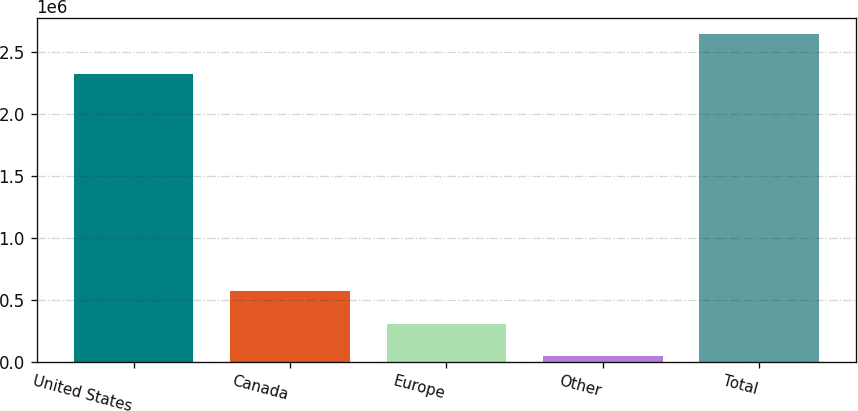<chart> <loc_0><loc_0><loc_500><loc_500><bar_chart><fcel>United States<fcel>Canada<fcel>Europe<fcel>Other<fcel>Total<nl><fcel>2.32252e+06<fcel>567680<fcel>307943<fcel>48206<fcel>2.64558e+06<nl></chart> 